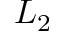Convert formula to latex. <formula><loc_0><loc_0><loc_500><loc_500>L _ { 2 }</formula> 